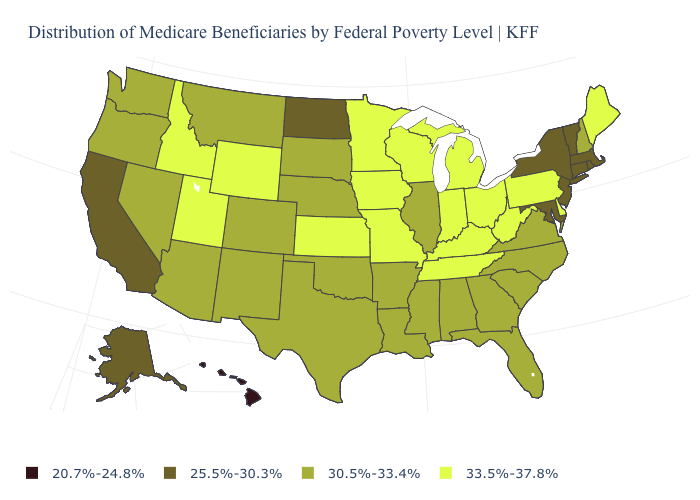Name the states that have a value in the range 20.7%-24.8%?
Be succinct. Hawaii. What is the value of Rhode Island?
Quick response, please. 25.5%-30.3%. Does the first symbol in the legend represent the smallest category?
Keep it brief. Yes. What is the value of Massachusetts?
Keep it brief. 25.5%-30.3%. Does Arizona have a lower value than Ohio?
Concise answer only. Yes. Does the map have missing data?
Keep it brief. No. What is the lowest value in the Northeast?
Quick response, please. 25.5%-30.3%. What is the highest value in the South ?
Write a very short answer. 33.5%-37.8%. Does Nevada have the highest value in the USA?
Write a very short answer. No. Does Maryland have the lowest value in the South?
Write a very short answer. Yes. Which states hav the highest value in the MidWest?
Answer briefly. Indiana, Iowa, Kansas, Michigan, Minnesota, Missouri, Ohio, Wisconsin. Does Nebraska have the lowest value in the USA?
Concise answer only. No. What is the lowest value in states that border Kentucky?
Concise answer only. 30.5%-33.4%. Does Alabama have the highest value in the South?
Keep it brief. No. What is the value of Nevada?
Quick response, please. 30.5%-33.4%. 